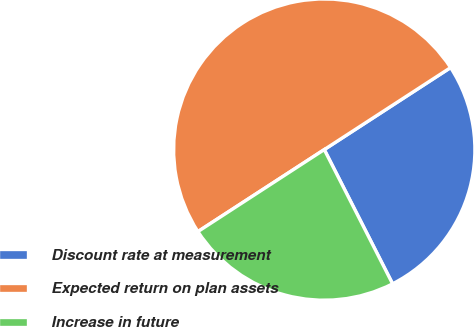Convert chart to OTSL. <chart><loc_0><loc_0><loc_500><loc_500><pie_chart><fcel>Discount rate at measurement<fcel>Expected return on plan assets<fcel>Increase in future<nl><fcel>26.67%<fcel>50.0%<fcel>23.33%<nl></chart> 